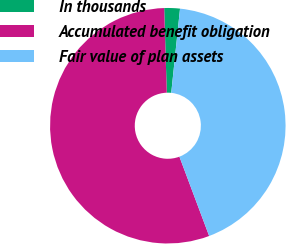<chart> <loc_0><loc_0><loc_500><loc_500><pie_chart><fcel>In thousands<fcel>Accumulated benefit obligation<fcel>Fair value of plan assets<nl><fcel>2.15%<fcel>55.22%<fcel>42.64%<nl></chart> 